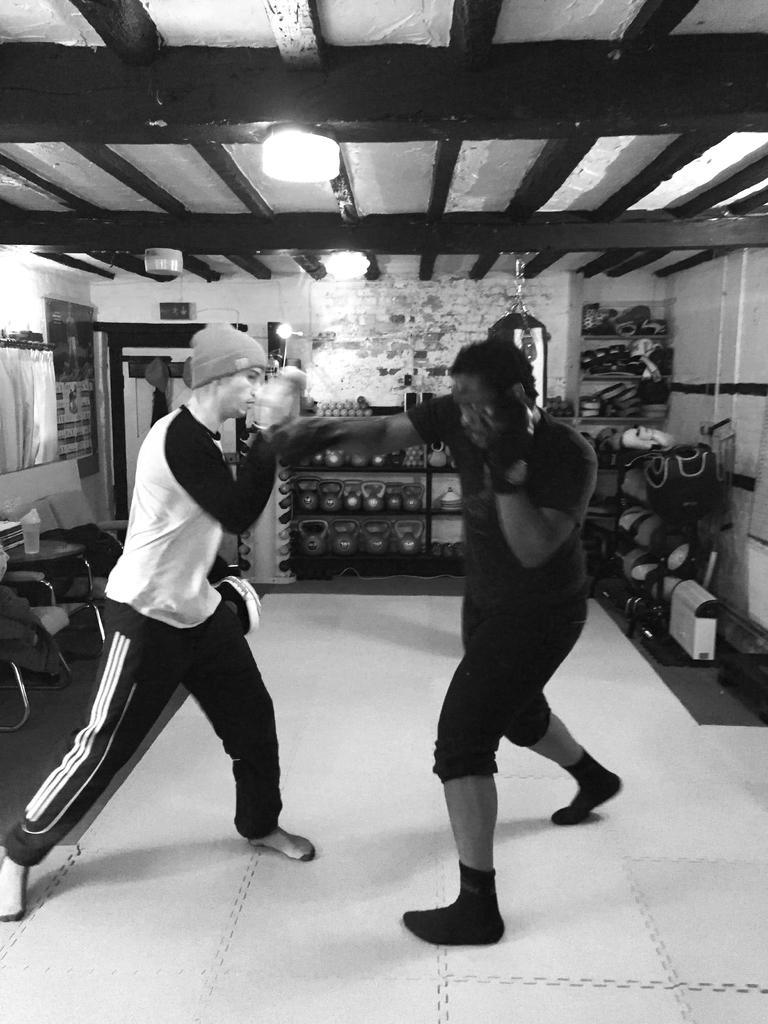Could you give a brief overview of what you see in this image? This picture shows couple of men practicing boxing and we see a man wore cap on his head and we see couple of shelves and a boxing bag and we see chairs and a bottle on the table. 